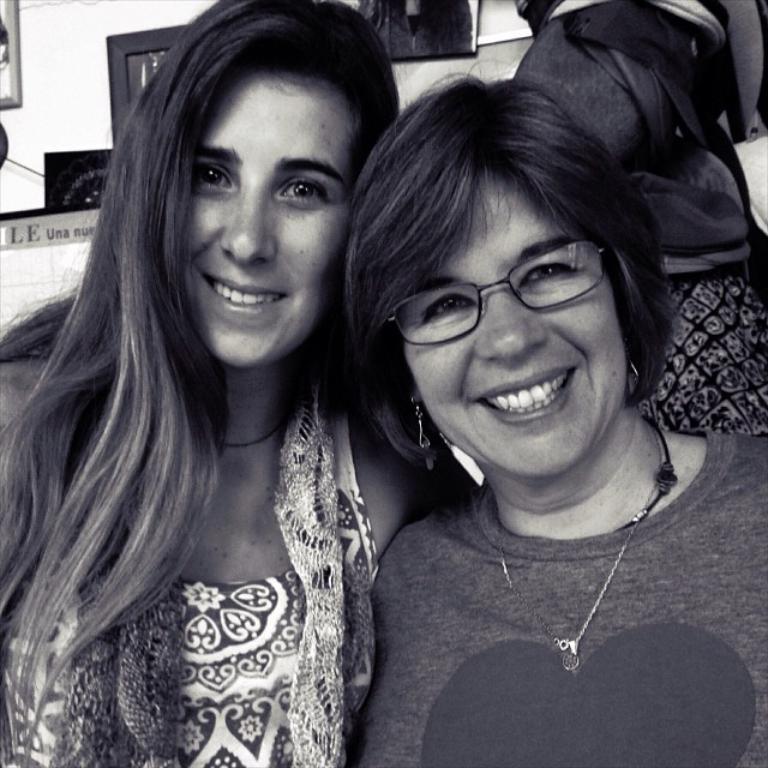Please provide a concise description of this image. There are two women smiling. In the background we can see bag,frames on a wall and objects. 